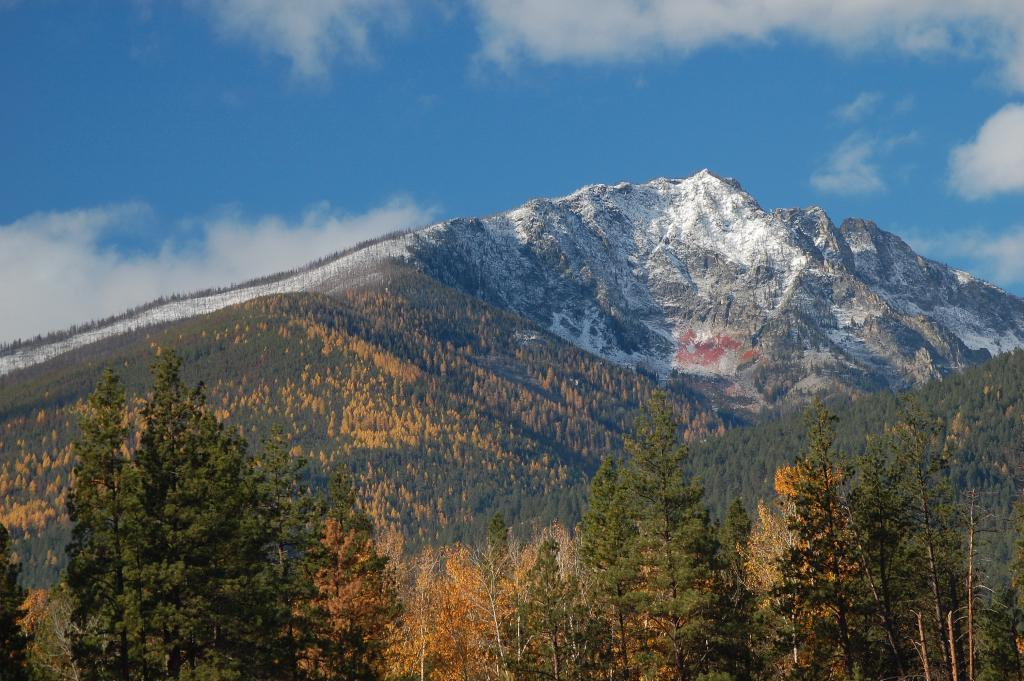What type of natural features can be seen in the image? There are trees and mountains in the image. What is visible in the background of the image? The sky is visible in the background of the image. How many gold cards are visible in the image? There are no gold cards present in the image. What type of seat can be seen in the image? There is no seat visible in the image; it features trees, mountains, and the sky. 